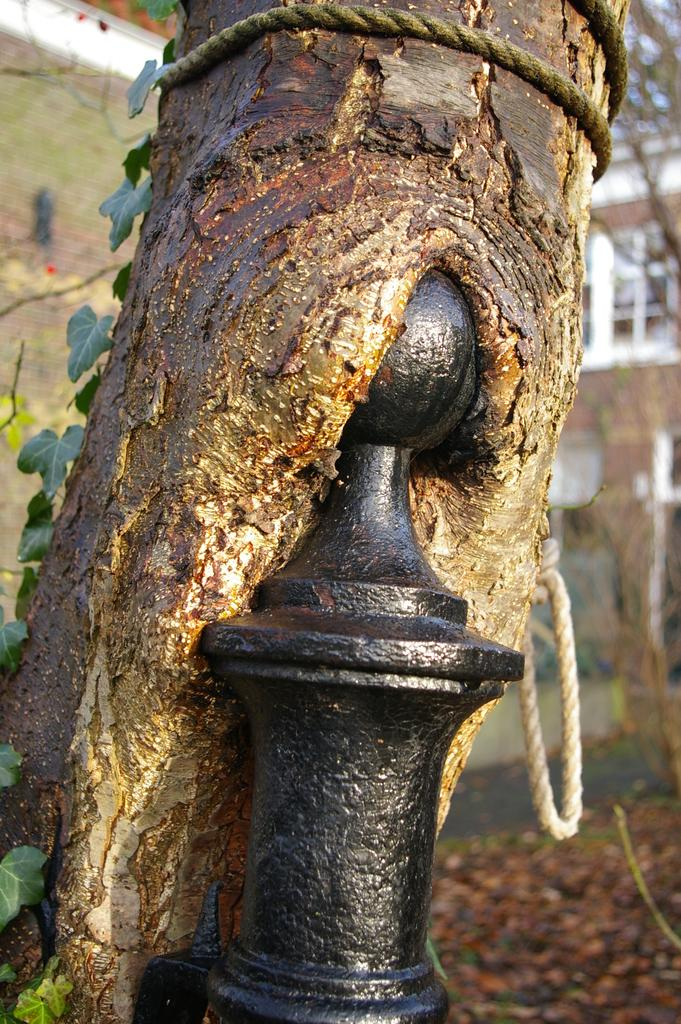What is located in the center of the image? There is a pole, a tree, and a rope in the center of the image. What can be seen in the background of the image? There is a building, a wall, and a window in the background of the image. What type of sign is hanging from the pole in the image? There is no sign hanging from the pole in the image; only the pole, tree, and rope are present. Can you tell me how many lawyers are visible in the image? There are no lawyers present in the image. 